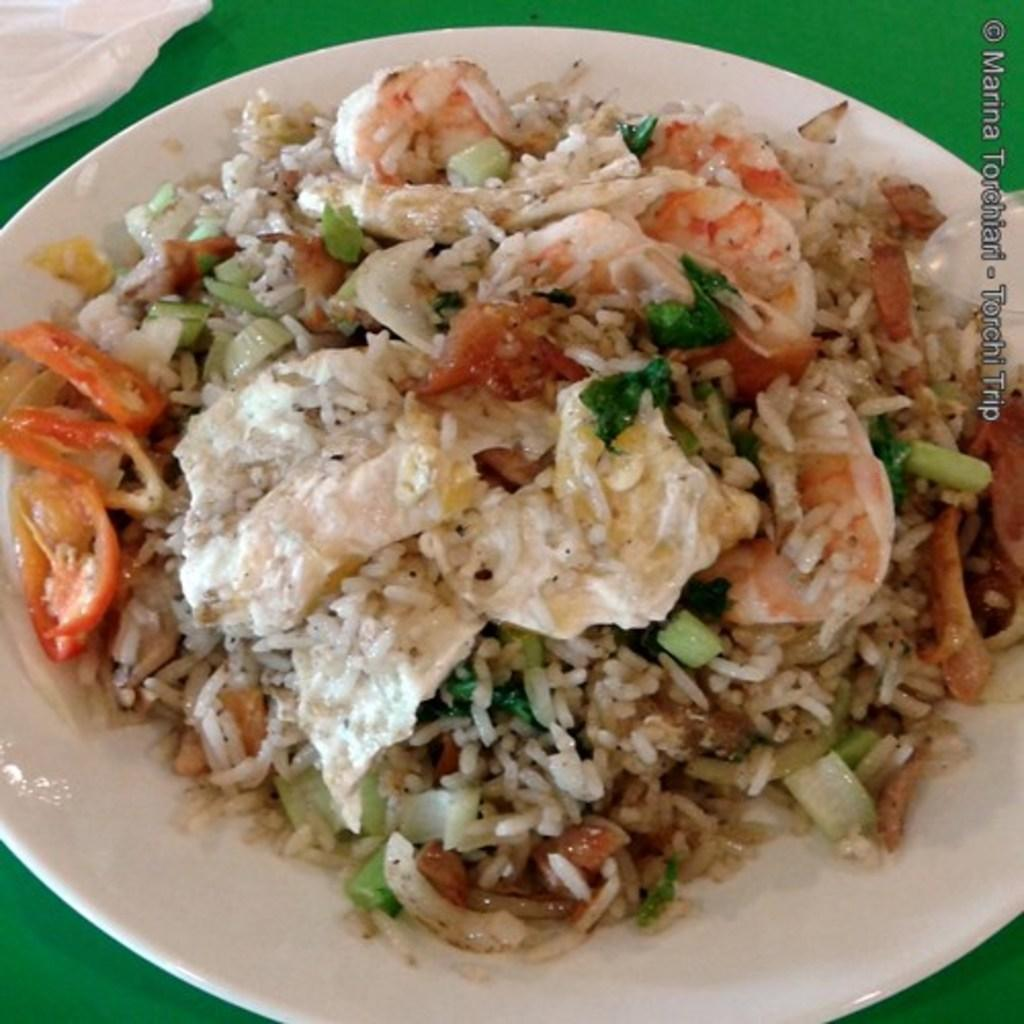What is on the plate that is visible in the image? There is a plate containing food in the image. What utensil is placed on the surface in the image? There is a spoon placed on the surface in the image. What type of material is visible at the top of the image? There is a cloth visible at the top of the image. Where is the text located in the image? The text is on the left side of the image. What type of music can be heard playing in the background of the image? There is no music or audio present in the image; it is a still image. 